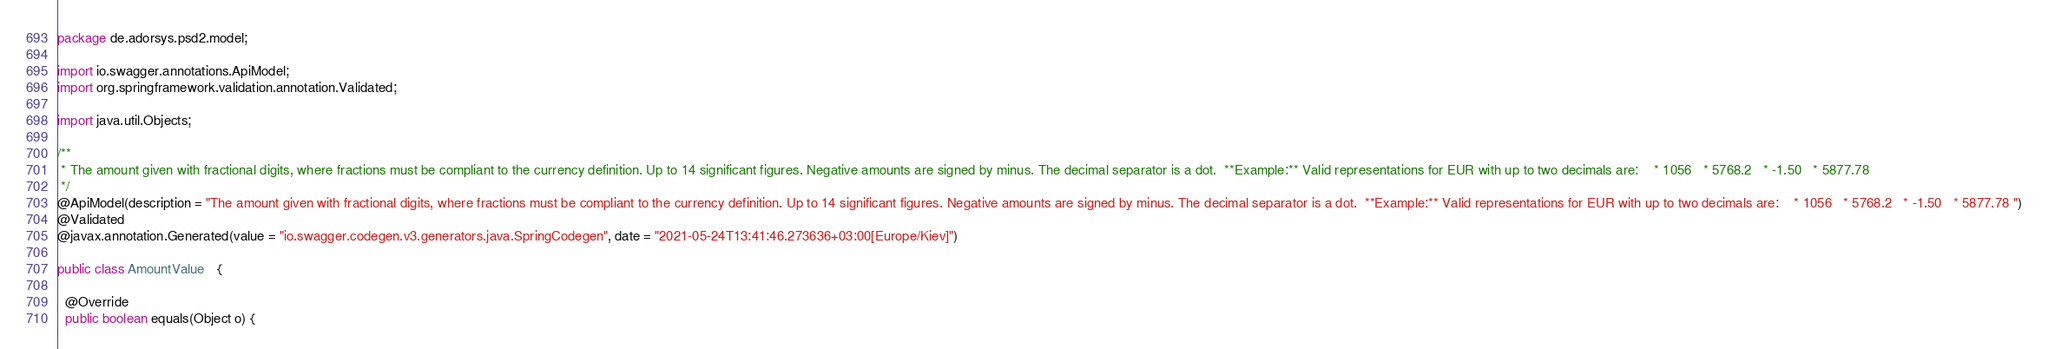<code> <loc_0><loc_0><loc_500><loc_500><_Java_>package de.adorsys.psd2.model;

import io.swagger.annotations.ApiModel;
import org.springframework.validation.annotation.Validated;

import java.util.Objects;

/**
 * The amount given with fractional digits, where fractions must be compliant to the currency definition. Up to 14 significant figures. Negative amounts are signed by minus. The decimal separator is a dot.  **Example:** Valid representations for EUR with up to two decimals are:    * 1056   * 5768.2   * -1.50   * 5877.78
 */
@ApiModel(description = "The amount given with fractional digits, where fractions must be compliant to the currency definition. Up to 14 significant figures. Negative amounts are signed by minus. The decimal separator is a dot.  **Example:** Valid representations for EUR with up to two decimals are:    * 1056   * 5768.2   * -1.50   * 5877.78 ")
@Validated
@javax.annotation.Generated(value = "io.swagger.codegen.v3.generators.java.SpringCodegen", date = "2021-05-24T13:41:46.273636+03:00[Europe/Kiev]")

public class AmountValue   {

  @Override
  public boolean equals(Object o) {</code> 